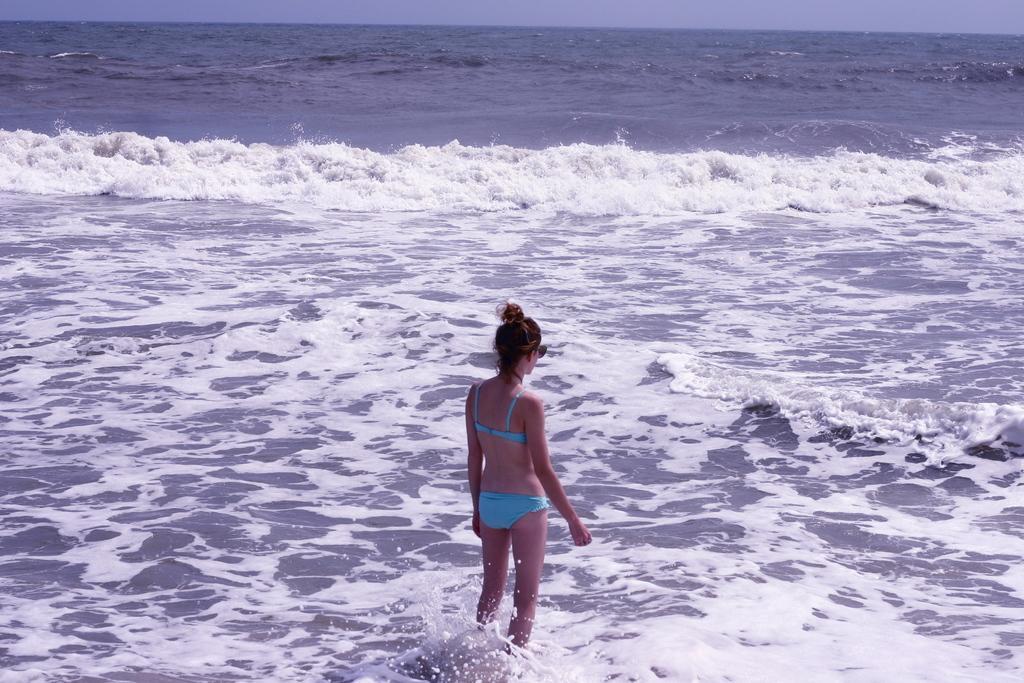Can you describe this image briefly? In the image there is a woman standing in the water of a sea. 